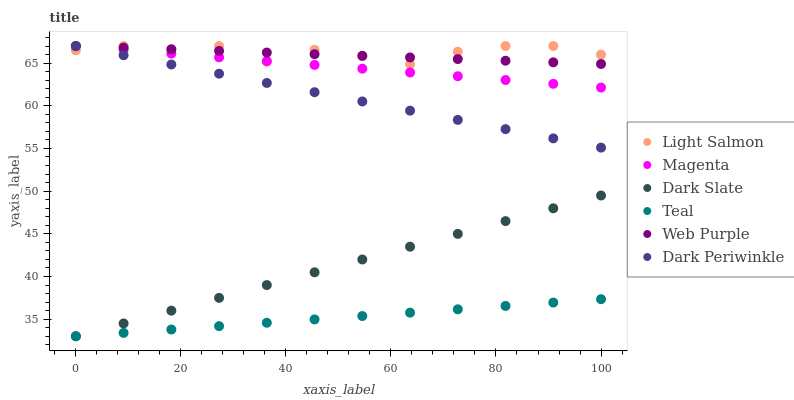Does Teal have the minimum area under the curve?
Answer yes or no. Yes. Does Light Salmon have the maximum area under the curve?
Answer yes or no. Yes. Does Dark Slate have the minimum area under the curve?
Answer yes or no. No. Does Dark Slate have the maximum area under the curve?
Answer yes or no. No. Is Web Purple the smoothest?
Answer yes or no. Yes. Is Light Salmon the roughest?
Answer yes or no. Yes. Is Dark Slate the smoothest?
Answer yes or no. No. Is Dark Slate the roughest?
Answer yes or no. No. Does Dark Slate have the lowest value?
Answer yes or no. Yes. Does Web Purple have the lowest value?
Answer yes or no. No. Does Dark Periwinkle have the highest value?
Answer yes or no. Yes. Does Dark Slate have the highest value?
Answer yes or no. No. Is Teal less than Light Salmon?
Answer yes or no. Yes. Is Light Salmon greater than Teal?
Answer yes or no. Yes. Does Dark Periwinkle intersect Web Purple?
Answer yes or no. Yes. Is Dark Periwinkle less than Web Purple?
Answer yes or no. No. Is Dark Periwinkle greater than Web Purple?
Answer yes or no. No. Does Teal intersect Light Salmon?
Answer yes or no. No. 